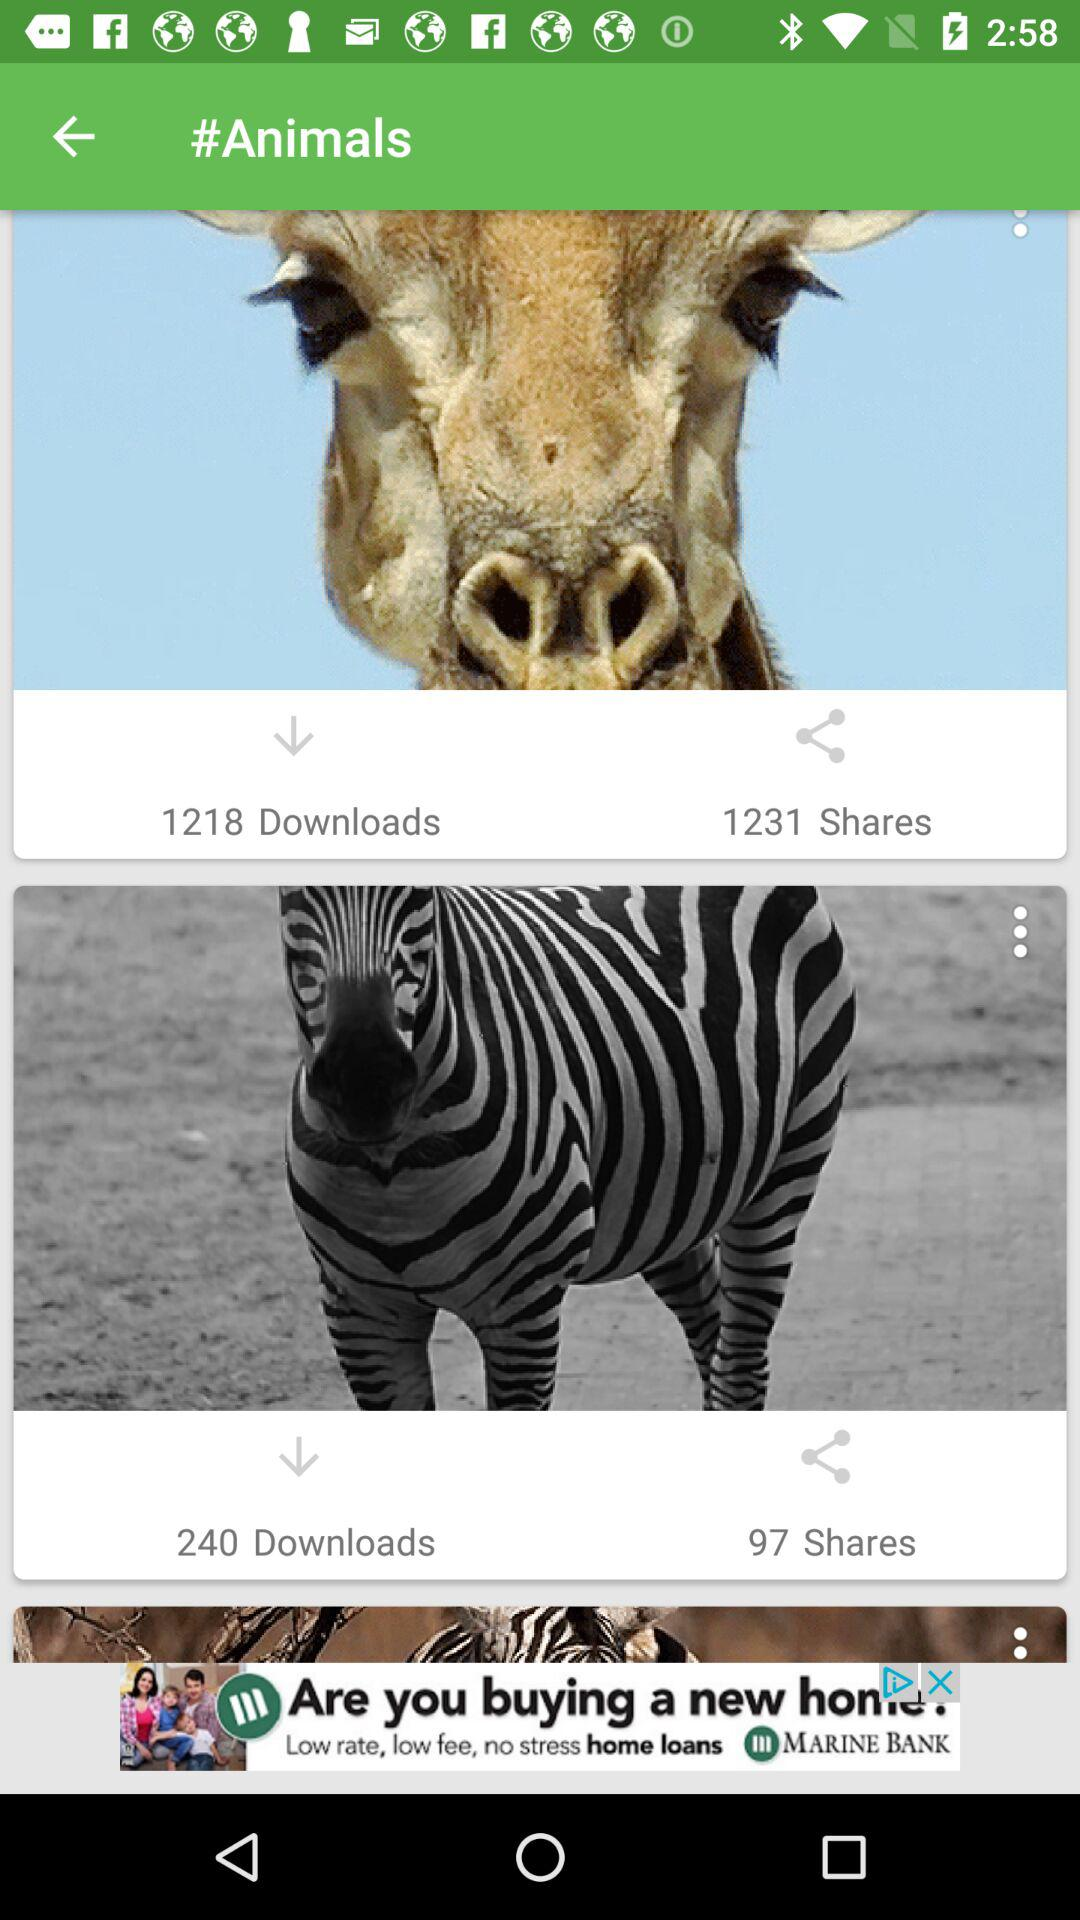How many more downloads does the giraffe have than the zebra?
Answer the question using a single word or phrase. 978 